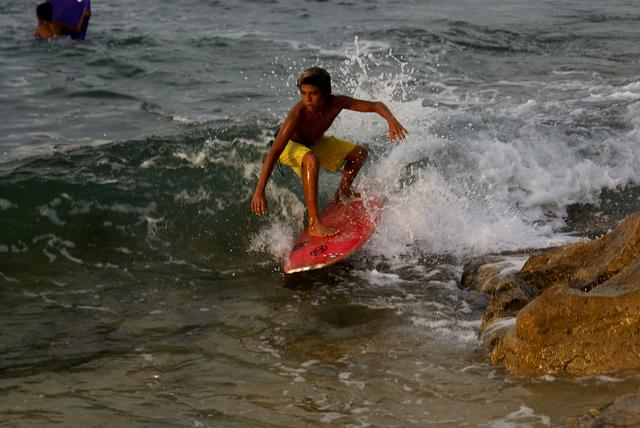What is the most obvious danger here? rocks 